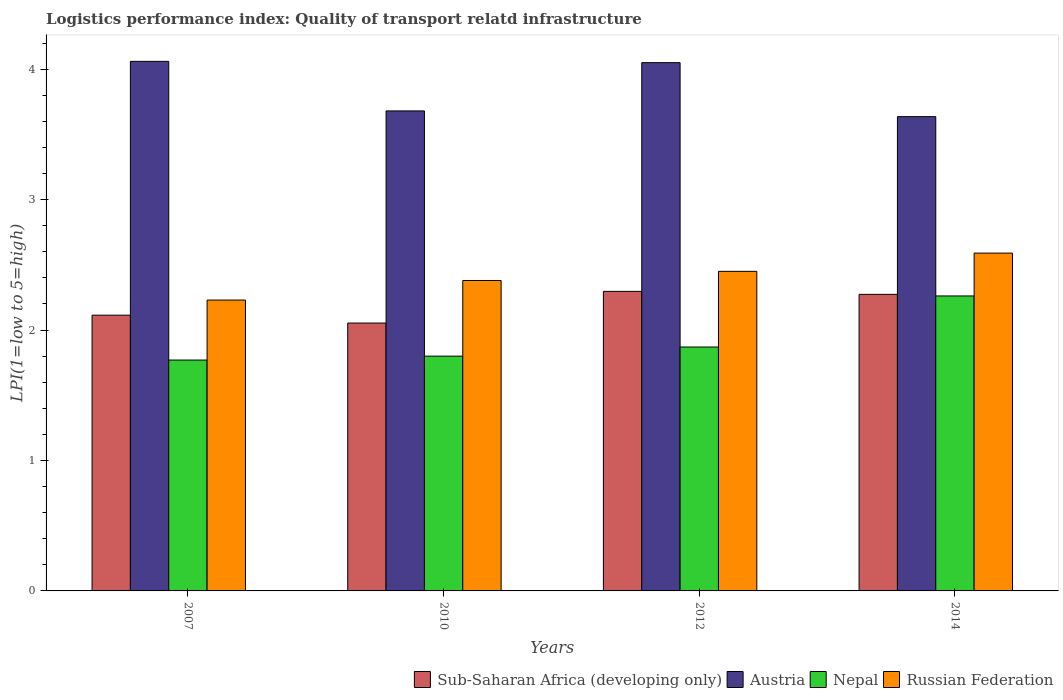How many bars are there on the 3rd tick from the right?
Ensure brevity in your answer.  4. What is the logistics performance index in Nepal in 2012?
Provide a short and direct response. 1.87. Across all years, what is the maximum logistics performance index in Austria?
Give a very brief answer. 4.06. Across all years, what is the minimum logistics performance index in Sub-Saharan Africa (developing only)?
Offer a terse response. 2.05. In which year was the logistics performance index in Russian Federation minimum?
Give a very brief answer. 2007. What is the total logistics performance index in Austria in the graph?
Your answer should be very brief. 15.43. What is the difference between the logistics performance index in Austria in 2010 and that in 2014?
Keep it short and to the point. 0.04. What is the difference between the logistics performance index in Nepal in 2007 and the logistics performance index in Austria in 2010?
Keep it short and to the point. -1.91. What is the average logistics performance index in Austria per year?
Offer a terse response. 3.86. In the year 2007, what is the difference between the logistics performance index in Sub-Saharan Africa (developing only) and logistics performance index in Nepal?
Make the answer very short. 0.34. What is the ratio of the logistics performance index in Nepal in 2007 to that in 2014?
Offer a terse response. 0.78. Is the difference between the logistics performance index in Sub-Saharan Africa (developing only) in 2007 and 2014 greater than the difference between the logistics performance index in Nepal in 2007 and 2014?
Provide a short and direct response. Yes. What is the difference between the highest and the second highest logistics performance index in Nepal?
Offer a terse response. 0.39. What is the difference between the highest and the lowest logistics performance index in Nepal?
Your answer should be very brief. 0.49. What does the 1st bar from the left in 2010 represents?
Your answer should be very brief. Sub-Saharan Africa (developing only). What does the 3rd bar from the right in 2007 represents?
Your answer should be very brief. Austria. How many bars are there?
Provide a short and direct response. 16. Are all the bars in the graph horizontal?
Provide a succinct answer. No. How many years are there in the graph?
Make the answer very short. 4. Does the graph contain grids?
Your answer should be compact. No. How are the legend labels stacked?
Your response must be concise. Horizontal. What is the title of the graph?
Provide a short and direct response. Logistics performance index: Quality of transport relatd infrastructure. Does "Swaziland" appear as one of the legend labels in the graph?
Give a very brief answer. No. What is the label or title of the Y-axis?
Offer a very short reply. LPI(1=low to 5=high). What is the LPI(1=low to 5=high) in Sub-Saharan Africa (developing only) in 2007?
Offer a very short reply. 2.11. What is the LPI(1=low to 5=high) of Austria in 2007?
Offer a terse response. 4.06. What is the LPI(1=low to 5=high) in Nepal in 2007?
Your answer should be compact. 1.77. What is the LPI(1=low to 5=high) of Russian Federation in 2007?
Provide a succinct answer. 2.23. What is the LPI(1=low to 5=high) of Sub-Saharan Africa (developing only) in 2010?
Provide a succinct answer. 2.05. What is the LPI(1=low to 5=high) of Austria in 2010?
Offer a very short reply. 3.68. What is the LPI(1=low to 5=high) of Russian Federation in 2010?
Your answer should be very brief. 2.38. What is the LPI(1=low to 5=high) of Sub-Saharan Africa (developing only) in 2012?
Offer a terse response. 2.3. What is the LPI(1=low to 5=high) in Austria in 2012?
Keep it short and to the point. 4.05. What is the LPI(1=low to 5=high) in Nepal in 2012?
Your answer should be very brief. 1.87. What is the LPI(1=low to 5=high) of Russian Federation in 2012?
Offer a terse response. 2.45. What is the LPI(1=low to 5=high) in Sub-Saharan Africa (developing only) in 2014?
Provide a short and direct response. 2.27. What is the LPI(1=low to 5=high) of Austria in 2014?
Ensure brevity in your answer.  3.64. What is the LPI(1=low to 5=high) of Nepal in 2014?
Keep it short and to the point. 2.26. What is the LPI(1=low to 5=high) in Russian Federation in 2014?
Make the answer very short. 2.59. Across all years, what is the maximum LPI(1=low to 5=high) in Sub-Saharan Africa (developing only)?
Give a very brief answer. 2.3. Across all years, what is the maximum LPI(1=low to 5=high) in Austria?
Give a very brief answer. 4.06. Across all years, what is the maximum LPI(1=low to 5=high) in Nepal?
Offer a very short reply. 2.26. Across all years, what is the maximum LPI(1=low to 5=high) of Russian Federation?
Offer a terse response. 2.59. Across all years, what is the minimum LPI(1=low to 5=high) in Sub-Saharan Africa (developing only)?
Give a very brief answer. 2.05. Across all years, what is the minimum LPI(1=low to 5=high) of Austria?
Make the answer very short. 3.64. Across all years, what is the minimum LPI(1=low to 5=high) in Nepal?
Provide a succinct answer. 1.77. Across all years, what is the minimum LPI(1=low to 5=high) in Russian Federation?
Ensure brevity in your answer.  2.23. What is the total LPI(1=low to 5=high) in Sub-Saharan Africa (developing only) in the graph?
Offer a terse response. 8.74. What is the total LPI(1=low to 5=high) in Austria in the graph?
Provide a short and direct response. 15.43. What is the total LPI(1=low to 5=high) of Nepal in the graph?
Provide a short and direct response. 7.7. What is the total LPI(1=low to 5=high) in Russian Federation in the graph?
Provide a short and direct response. 9.65. What is the difference between the LPI(1=low to 5=high) of Sub-Saharan Africa (developing only) in 2007 and that in 2010?
Offer a very short reply. 0.06. What is the difference between the LPI(1=low to 5=high) of Austria in 2007 and that in 2010?
Keep it short and to the point. 0.38. What is the difference between the LPI(1=low to 5=high) of Nepal in 2007 and that in 2010?
Provide a short and direct response. -0.03. What is the difference between the LPI(1=low to 5=high) in Sub-Saharan Africa (developing only) in 2007 and that in 2012?
Your response must be concise. -0.18. What is the difference between the LPI(1=low to 5=high) in Nepal in 2007 and that in 2012?
Your answer should be very brief. -0.1. What is the difference between the LPI(1=low to 5=high) in Russian Federation in 2007 and that in 2012?
Keep it short and to the point. -0.22. What is the difference between the LPI(1=low to 5=high) in Sub-Saharan Africa (developing only) in 2007 and that in 2014?
Provide a short and direct response. -0.16. What is the difference between the LPI(1=low to 5=high) in Austria in 2007 and that in 2014?
Your answer should be very brief. 0.42. What is the difference between the LPI(1=low to 5=high) in Nepal in 2007 and that in 2014?
Ensure brevity in your answer.  -0.49. What is the difference between the LPI(1=low to 5=high) of Russian Federation in 2007 and that in 2014?
Your response must be concise. -0.36. What is the difference between the LPI(1=low to 5=high) of Sub-Saharan Africa (developing only) in 2010 and that in 2012?
Offer a very short reply. -0.24. What is the difference between the LPI(1=low to 5=high) of Austria in 2010 and that in 2012?
Keep it short and to the point. -0.37. What is the difference between the LPI(1=low to 5=high) in Nepal in 2010 and that in 2012?
Provide a succinct answer. -0.07. What is the difference between the LPI(1=low to 5=high) of Russian Federation in 2010 and that in 2012?
Give a very brief answer. -0.07. What is the difference between the LPI(1=low to 5=high) of Sub-Saharan Africa (developing only) in 2010 and that in 2014?
Your answer should be compact. -0.22. What is the difference between the LPI(1=low to 5=high) of Austria in 2010 and that in 2014?
Offer a very short reply. 0.04. What is the difference between the LPI(1=low to 5=high) of Nepal in 2010 and that in 2014?
Provide a short and direct response. -0.46. What is the difference between the LPI(1=low to 5=high) of Russian Federation in 2010 and that in 2014?
Provide a succinct answer. -0.21. What is the difference between the LPI(1=low to 5=high) of Sub-Saharan Africa (developing only) in 2012 and that in 2014?
Provide a succinct answer. 0.02. What is the difference between the LPI(1=low to 5=high) of Austria in 2012 and that in 2014?
Offer a terse response. 0.41. What is the difference between the LPI(1=low to 5=high) of Nepal in 2012 and that in 2014?
Keep it short and to the point. -0.39. What is the difference between the LPI(1=low to 5=high) in Russian Federation in 2012 and that in 2014?
Your response must be concise. -0.14. What is the difference between the LPI(1=low to 5=high) in Sub-Saharan Africa (developing only) in 2007 and the LPI(1=low to 5=high) in Austria in 2010?
Your response must be concise. -1.57. What is the difference between the LPI(1=low to 5=high) in Sub-Saharan Africa (developing only) in 2007 and the LPI(1=low to 5=high) in Nepal in 2010?
Your answer should be compact. 0.31. What is the difference between the LPI(1=low to 5=high) in Sub-Saharan Africa (developing only) in 2007 and the LPI(1=low to 5=high) in Russian Federation in 2010?
Your answer should be very brief. -0.27. What is the difference between the LPI(1=low to 5=high) of Austria in 2007 and the LPI(1=low to 5=high) of Nepal in 2010?
Your answer should be very brief. 2.26. What is the difference between the LPI(1=low to 5=high) of Austria in 2007 and the LPI(1=low to 5=high) of Russian Federation in 2010?
Provide a succinct answer. 1.68. What is the difference between the LPI(1=low to 5=high) of Nepal in 2007 and the LPI(1=low to 5=high) of Russian Federation in 2010?
Make the answer very short. -0.61. What is the difference between the LPI(1=low to 5=high) of Sub-Saharan Africa (developing only) in 2007 and the LPI(1=low to 5=high) of Austria in 2012?
Ensure brevity in your answer.  -1.94. What is the difference between the LPI(1=low to 5=high) in Sub-Saharan Africa (developing only) in 2007 and the LPI(1=low to 5=high) in Nepal in 2012?
Ensure brevity in your answer.  0.24. What is the difference between the LPI(1=low to 5=high) of Sub-Saharan Africa (developing only) in 2007 and the LPI(1=low to 5=high) of Russian Federation in 2012?
Make the answer very short. -0.34. What is the difference between the LPI(1=low to 5=high) in Austria in 2007 and the LPI(1=low to 5=high) in Nepal in 2012?
Keep it short and to the point. 2.19. What is the difference between the LPI(1=low to 5=high) in Austria in 2007 and the LPI(1=low to 5=high) in Russian Federation in 2012?
Keep it short and to the point. 1.61. What is the difference between the LPI(1=low to 5=high) in Nepal in 2007 and the LPI(1=low to 5=high) in Russian Federation in 2012?
Make the answer very short. -0.68. What is the difference between the LPI(1=low to 5=high) of Sub-Saharan Africa (developing only) in 2007 and the LPI(1=low to 5=high) of Austria in 2014?
Your answer should be compact. -1.52. What is the difference between the LPI(1=low to 5=high) of Sub-Saharan Africa (developing only) in 2007 and the LPI(1=low to 5=high) of Nepal in 2014?
Your response must be concise. -0.15. What is the difference between the LPI(1=low to 5=high) in Sub-Saharan Africa (developing only) in 2007 and the LPI(1=low to 5=high) in Russian Federation in 2014?
Make the answer very short. -0.48. What is the difference between the LPI(1=low to 5=high) in Austria in 2007 and the LPI(1=low to 5=high) in Nepal in 2014?
Ensure brevity in your answer.  1.8. What is the difference between the LPI(1=low to 5=high) of Austria in 2007 and the LPI(1=low to 5=high) of Russian Federation in 2014?
Your response must be concise. 1.47. What is the difference between the LPI(1=low to 5=high) in Nepal in 2007 and the LPI(1=low to 5=high) in Russian Federation in 2014?
Give a very brief answer. -0.82. What is the difference between the LPI(1=low to 5=high) in Sub-Saharan Africa (developing only) in 2010 and the LPI(1=low to 5=high) in Austria in 2012?
Your response must be concise. -2. What is the difference between the LPI(1=low to 5=high) in Sub-Saharan Africa (developing only) in 2010 and the LPI(1=low to 5=high) in Nepal in 2012?
Offer a terse response. 0.18. What is the difference between the LPI(1=low to 5=high) in Sub-Saharan Africa (developing only) in 2010 and the LPI(1=low to 5=high) in Russian Federation in 2012?
Your response must be concise. -0.4. What is the difference between the LPI(1=low to 5=high) of Austria in 2010 and the LPI(1=low to 5=high) of Nepal in 2012?
Provide a succinct answer. 1.81. What is the difference between the LPI(1=low to 5=high) in Austria in 2010 and the LPI(1=low to 5=high) in Russian Federation in 2012?
Your answer should be compact. 1.23. What is the difference between the LPI(1=low to 5=high) in Nepal in 2010 and the LPI(1=low to 5=high) in Russian Federation in 2012?
Provide a short and direct response. -0.65. What is the difference between the LPI(1=low to 5=high) of Sub-Saharan Africa (developing only) in 2010 and the LPI(1=low to 5=high) of Austria in 2014?
Your answer should be compact. -1.58. What is the difference between the LPI(1=low to 5=high) of Sub-Saharan Africa (developing only) in 2010 and the LPI(1=low to 5=high) of Nepal in 2014?
Provide a succinct answer. -0.21. What is the difference between the LPI(1=low to 5=high) in Sub-Saharan Africa (developing only) in 2010 and the LPI(1=low to 5=high) in Russian Federation in 2014?
Offer a very short reply. -0.54. What is the difference between the LPI(1=low to 5=high) in Austria in 2010 and the LPI(1=low to 5=high) in Nepal in 2014?
Your answer should be very brief. 1.42. What is the difference between the LPI(1=low to 5=high) in Austria in 2010 and the LPI(1=low to 5=high) in Russian Federation in 2014?
Your answer should be very brief. 1.09. What is the difference between the LPI(1=low to 5=high) of Nepal in 2010 and the LPI(1=low to 5=high) of Russian Federation in 2014?
Offer a very short reply. -0.79. What is the difference between the LPI(1=low to 5=high) of Sub-Saharan Africa (developing only) in 2012 and the LPI(1=low to 5=high) of Austria in 2014?
Keep it short and to the point. -1.34. What is the difference between the LPI(1=low to 5=high) in Sub-Saharan Africa (developing only) in 2012 and the LPI(1=low to 5=high) in Nepal in 2014?
Your response must be concise. 0.04. What is the difference between the LPI(1=low to 5=high) in Sub-Saharan Africa (developing only) in 2012 and the LPI(1=low to 5=high) in Russian Federation in 2014?
Make the answer very short. -0.29. What is the difference between the LPI(1=low to 5=high) of Austria in 2012 and the LPI(1=low to 5=high) of Nepal in 2014?
Your answer should be compact. 1.79. What is the difference between the LPI(1=low to 5=high) of Austria in 2012 and the LPI(1=low to 5=high) of Russian Federation in 2014?
Make the answer very short. 1.46. What is the difference between the LPI(1=low to 5=high) of Nepal in 2012 and the LPI(1=low to 5=high) of Russian Federation in 2014?
Give a very brief answer. -0.72. What is the average LPI(1=low to 5=high) of Sub-Saharan Africa (developing only) per year?
Your answer should be compact. 2.18. What is the average LPI(1=low to 5=high) of Austria per year?
Make the answer very short. 3.86. What is the average LPI(1=low to 5=high) in Nepal per year?
Provide a succinct answer. 1.93. What is the average LPI(1=low to 5=high) in Russian Federation per year?
Provide a short and direct response. 2.41. In the year 2007, what is the difference between the LPI(1=low to 5=high) in Sub-Saharan Africa (developing only) and LPI(1=low to 5=high) in Austria?
Make the answer very short. -1.95. In the year 2007, what is the difference between the LPI(1=low to 5=high) in Sub-Saharan Africa (developing only) and LPI(1=low to 5=high) in Nepal?
Give a very brief answer. 0.34. In the year 2007, what is the difference between the LPI(1=low to 5=high) of Sub-Saharan Africa (developing only) and LPI(1=low to 5=high) of Russian Federation?
Give a very brief answer. -0.12. In the year 2007, what is the difference between the LPI(1=low to 5=high) in Austria and LPI(1=low to 5=high) in Nepal?
Offer a very short reply. 2.29. In the year 2007, what is the difference between the LPI(1=low to 5=high) in Austria and LPI(1=low to 5=high) in Russian Federation?
Make the answer very short. 1.83. In the year 2007, what is the difference between the LPI(1=low to 5=high) of Nepal and LPI(1=low to 5=high) of Russian Federation?
Provide a succinct answer. -0.46. In the year 2010, what is the difference between the LPI(1=low to 5=high) in Sub-Saharan Africa (developing only) and LPI(1=low to 5=high) in Austria?
Offer a very short reply. -1.63. In the year 2010, what is the difference between the LPI(1=low to 5=high) of Sub-Saharan Africa (developing only) and LPI(1=low to 5=high) of Nepal?
Offer a terse response. 0.25. In the year 2010, what is the difference between the LPI(1=low to 5=high) of Sub-Saharan Africa (developing only) and LPI(1=low to 5=high) of Russian Federation?
Provide a succinct answer. -0.33. In the year 2010, what is the difference between the LPI(1=low to 5=high) of Austria and LPI(1=low to 5=high) of Nepal?
Give a very brief answer. 1.88. In the year 2010, what is the difference between the LPI(1=low to 5=high) of Nepal and LPI(1=low to 5=high) of Russian Federation?
Offer a terse response. -0.58. In the year 2012, what is the difference between the LPI(1=low to 5=high) in Sub-Saharan Africa (developing only) and LPI(1=low to 5=high) in Austria?
Your response must be concise. -1.75. In the year 2012, what is the difference between the LPI(1=low to 5=high) in Sub-Saharan Africa (developing only) and LPI(1=low to 5=high) in Nepal?
Provide a succinct answer. 0.43. In the year 2012, what is the difference between the LPI(1=low to 5=high) of Sub-Saharan Africa (developing only) and LPI(1=low to 5=high) of Russian Federation?
Your answer should be very brief. -0.15. In the year 2012, what is the difference between the LPI(1=low to 5=high) of Austria and LPI(1=low to 5=high) of Nepal?
Make the answer very short. 2.18. In the year 2012, what is the difference between the LPI(1=low to 5=high) of Nepal and LPI(1=low to 5=high) of Russian Federation?
Provide a succinct answer. -0.58. In the year 2014, what is the difference between the LPI(1=low to 5=high) in Sub-Saharan Africa (developing only) and LPI(1=low to 5=high) in Austria?
Your answer should be compact. -1.36. In the year 2014, what is the difference between the LPI(1=low to 5=high) of Sub-Saharan Africa (developing only) and LPI(1=low to 5=high) of Nepal?
Make the answer very short. 0.01. In the year 2014, what is the difference between the LPI(1=low to 5=high) in Sub-Saharan Africa (developing only) and LPI(1=low to 5=high) in Russian Federation?
Your answer should be compact. -0.32. In the year 2014, what is the difference between the LPI(1=low to 5=high) in Austria and LPI(1=low to 5=high) in Nepal?
Make the answer very short. 1.37. In the year 2014, what is the difference between the LPI(1=low to 5=high) in Austria and LPI(1=low to 5=high) in Russian Federation?
Make the answer very short. 1.05. In the year 2014, what is the difference between the LPI(1=low to 5=high) in Nepal and LPI(1=low to 5=high) in Russian Federation?
Offer a very short reply. -0.33. What is the ratio of the LPI(1=low to 5=high) of Sub-Saharan Africa (developing only) in 2007 to that in 2010?
Offer a very short reply. 1.03. What is the ratio of the LPI(1=low to 5=high) in Austria in 2007 to that in 2010?
Give a very brief answer. 1.1. What is the ratio of the LPI(1=low to 5=high) of Nepal in 2007 to that in 2010?
Make the answer very short. 0.98. What is the ratio of the LPI(1=low to 5=high) of Russian Federation in 2007 to that in 2010?
Give a very brief answer. 0.94. What is the ratio of the LPI(1=low to 5=high) of Sub-Saharan Africa (developing only) in 2007 to that in 2012?
Ensure brevity in your answer.  0.92. What is the ratio of the LPI(1=low to 5=high) of Austria in 2007 to that in 2012?
Offer a very short reply. 1. What is the ratio of the LPI(1=low to 5=high) of Nepal in 2007 to that in 2012?
Ensure brevity in your answer.  0.95. What is the ratio of the LPI(1=low to 5=high) in Russian Federation in 2007 to that in 2012?
Offer a very short reply. 0.91. What is the ratio of the LPI(1=low to 5=high) in Sub-Saharan Africa (developing only) in 2007 to that in 2014?
Your response must be concise. 0.93. What is the ratio of the LPI(1=low to 5=high) of Austria in 2007 to that in 2014?
Give a very brief answer. 1.12. What is the ratio of the LPI(1=low to 5=high) of Nepal in 2007 to that in 2014?
Make the answer very short. 0.78. What is the ratio of the LPI(1=low to 5=high) of Russian Federation in 2007 to that in 2014?
Provide a succinct answer. 0.86. What is the ratio of the LPI(1=low to 5=high) of Sub-Saharan Africa (developing only) in 2010 to that in 2012?
Your answer should be very brief. 0.89. What is the ratio of the LPI(1=low to 5=high) of Austria in 2010 to that in 2012?
Keep it short and to the point. 0.91. What is the ratio of the LPI(1=low to 5=high) in Nepal in 2010 to that in 2012?
Make the answer very short. 0.96. What is the ratio of the LPI(1=low to 5=high) in Russian Federation in 2010 to that in 2012?
Give a very brief answer. 0.97. What is the ratio of the LPI(1=low to 5=high) in Sub-Saharan Africa (developing only) in 2010 to that in 2014?
Offer a terse response. 0.9. What is the ratio of the LPI(1=low to 5=high) of Austria in 2010 to that in 2014?
Provide a short and direct response. 1.01. What is the ratio of the LPI(1=low to 5=high) of Nepal in 2010 to that in 2014?
Ensure brevity in your answer.  0.8. What is the ratio of the LPI(1=low to 5=high) of Russian Federation in 2010 to that in 2014?
Keep it short and to the point. 0.92. What is the ratio of the LPI(1=low to 5=high) in Austria in 2012 to that in 2014?
Ensure brevity in your answer.  1.11. What is the ratio of the LPI(1=low to 5=high) in Nepal in 2012 to that in 2014?
Your answer should be very brief. 0.83. What is the ratio of the LPI(1=low to 5=high) of Russian Federation in 2012 to that in 2014?
Ensure brevity in your answer.  0.95. What is the difference between the highest and the second highest LPI(1=low to 5=high) in Sub-Saharan Africa (developing only)?
Your answer should be compact. 0.02. What is the difference between the highest and the second highest LPI(1=low to 5=high) of Austria?
Your answer should be very brief. 0.01. What is the difference between the highest and the second highest LPI(1=low to 5=high) of Nepal?
Provide a succinct answer. 0.39. What is the difference between the highest and the second highest LPI(1=low to 5=high) in Russian Federation?
Ensure brevity in your answer.  0.14. What is the difference between the highest and the lowest LPI(1=low to 5=high) in Sub-Saharan Africa (developing only)?
Offer a very short reply. 0.24. What is the difference between the highest and the lowest LPI(1=low to 5=high) of Austria?
Offer a very short reply. 0.42. What is the difference between the highest and the lowest LPI(1=low to 5=high) of Nepal?
Offer a very short reply. 0.49. What is the difference between the highest and the lowest LPI(1=low to 5=high) of Russian Federation?
Provide a succinct answer. 0.36. 